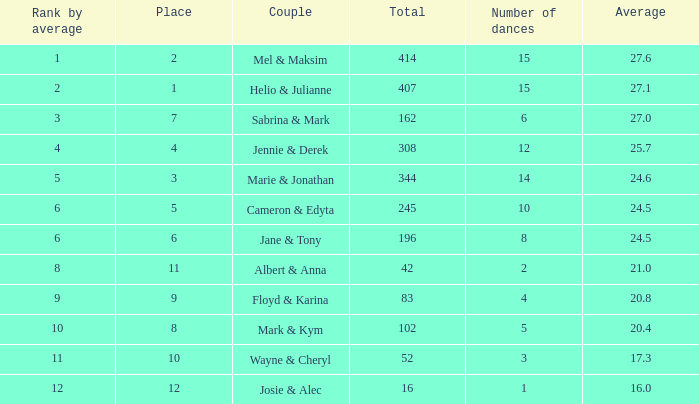What is the average when the position by average exceeds 12? None. 